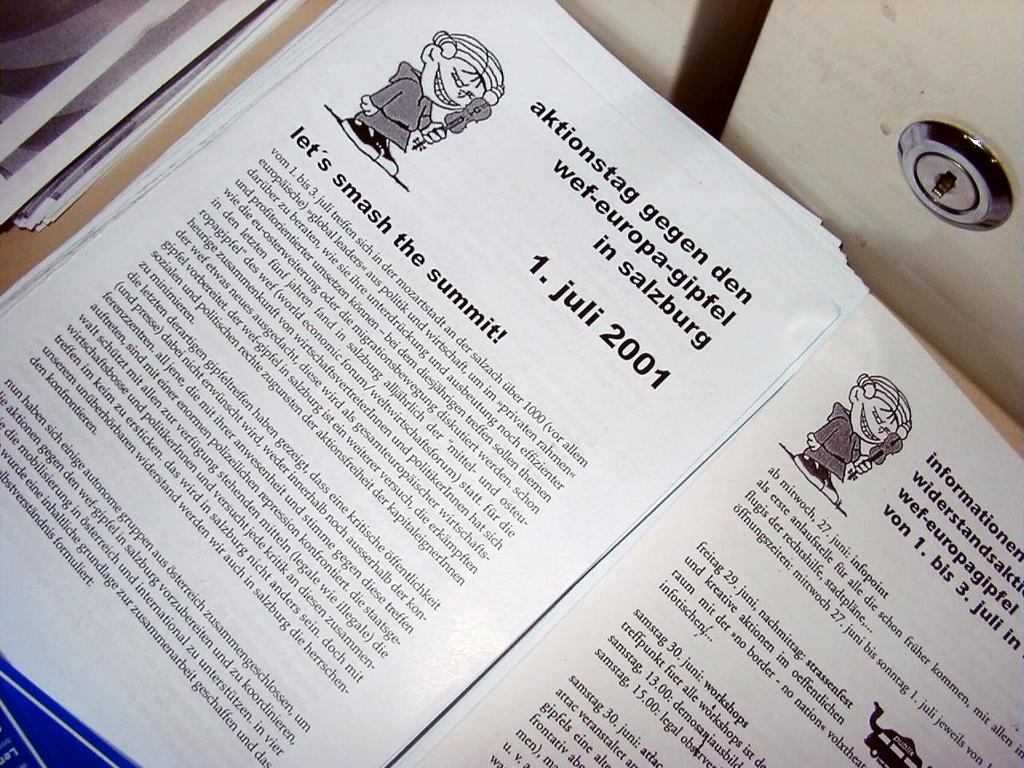<image>
Summarize the visual content of the image. A black and white print book open to a page titled Let's smash the summit. 